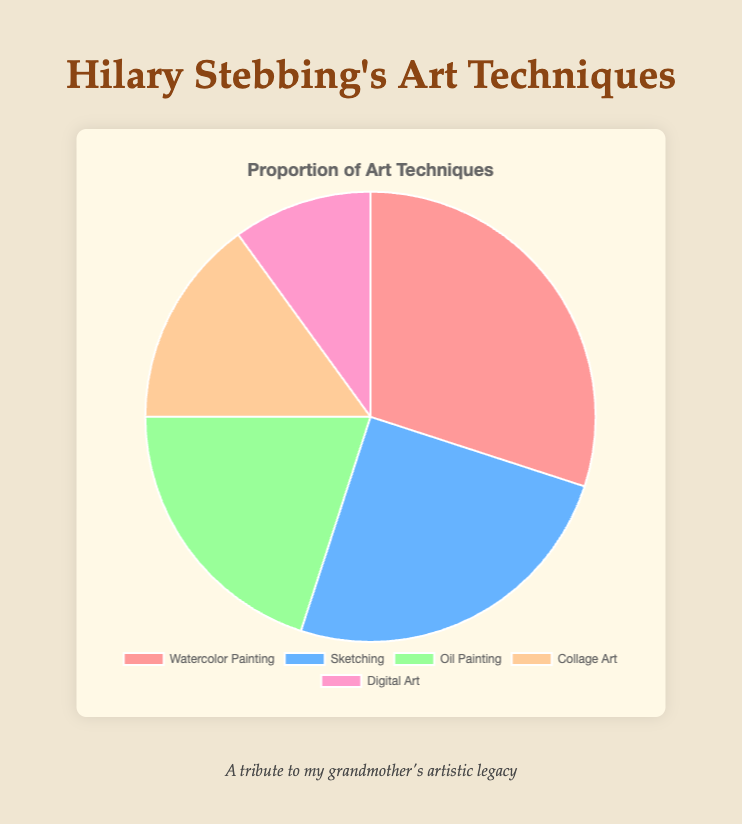What art technique has the highest proportion in the pie chart? By looking at the pie chart, it is clear that the segment representing "Watercolor Painting" is the largest. This indicates that watercolor painting has the highest proportion among all listed techniques.
Answer: Watercolor Painting What is the combined percentage of Oil Painting and Digital Art? The percentage for Oil Painting is 20%, and for Digital Art, it is 10%. Adding these percentages together, we get 20% + 10% = 30%.
Answer: 30% Is Sketching more or less frequent than Collage Art? By observing the pie chart, the segment for "Sketching" is larger than the segment for "Collage Art". This indicates that Sketching is more frequent as compared to Collage Art.
Answer: More What is the color of the segment representing Collage Art? In the pie chart, the segment representing "Collage Art" is depicted in a particular color that can be visually distinguished. The color of the Collage Art segment is orange.
Answer: Orange Which technique has the smallest proportion, and what is its percentage? By analyzing the pie chart, the smallest segment represents "Digital Art", which has a percentage of 10%.
Answer: Digital Art, 10% What percentage of Hilary Stebbing's art techniques are represented by Watercolor Painting and Sketching combined? The percentage for Watercolor Painting is 30%, and for Sketching, it is 25%. Adding these percentages together, you get 30% + 25% = 55%.
Answer: 55% How much larger is the proportion of Watercolor Painting compared to Digital Art? The percentage for Watercolor Painting is 30% and for Digital Art it is 10%. By subtracting the smaller percentage from the larger percentage, we get 30% - 10% = 20%.
Answer: 20% What is the average percentage of the five art techniques? The percentages are 30%, 25%, 20%, 15%, and 10%. Summing these values gives 30 + 25 + 20 + 15 + 10 = 100. Dividing by the number of techniques (5), we get 100 / 5 = 20%.
Answer: 20% Is Oil Painting or Sketching less common in the pie chart? By comparing the segments in the pie chart, the percentage for Oil Painting is 20% while that for Sketching is 25%. Since Oil Painting has a lower percentage, it is less common than Sketching.
Answer: Oil Painting How much more frequent is Collage Art than Digital Art? The percentage for Collage Art is 15%, and for Digital Art, it is 10%. By subtracting the smaller percentage from the larger percentage, we get 15% - 10% = 5%.
Answer: 5% 